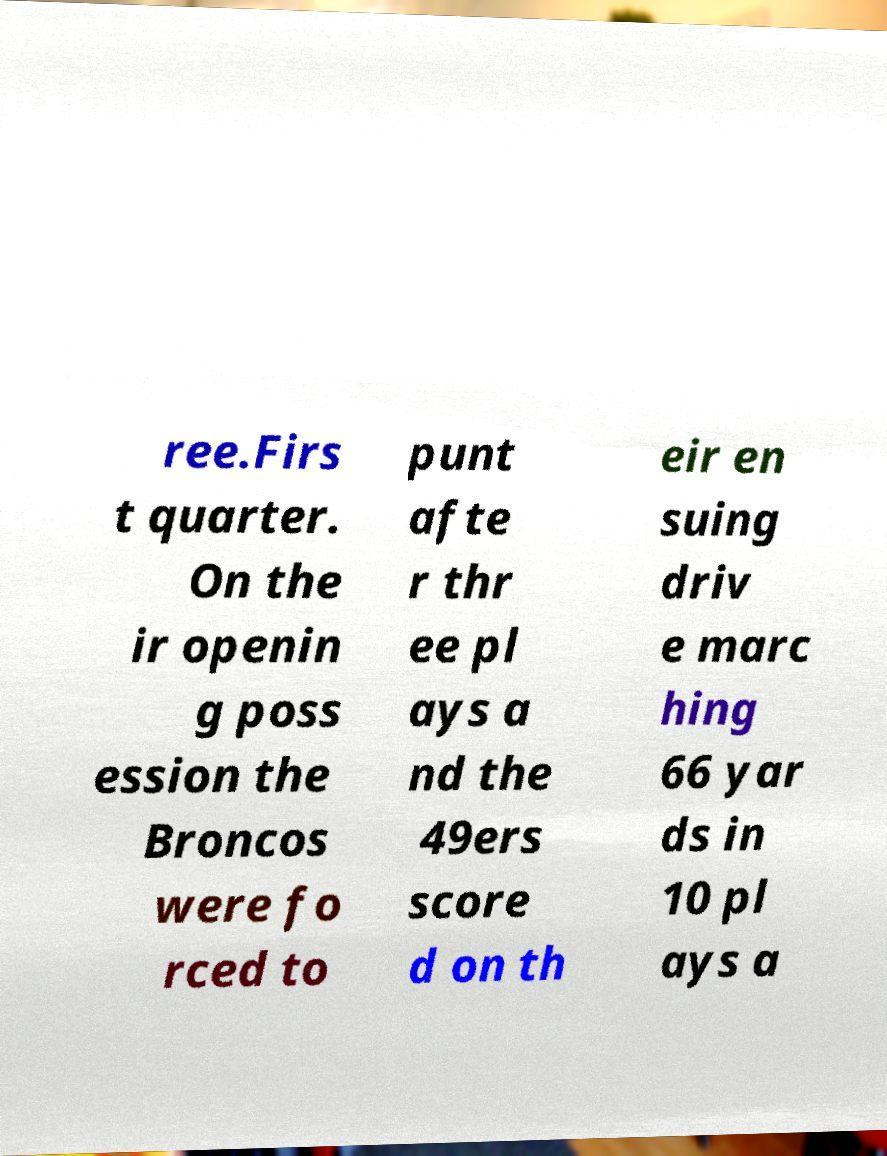There's text embedded in this image that I need extracted. Can you transcribe it verbatim? ree.Firs t quarter. On the ir openin g poss ession the Broncos were fo rced to punt afte r thr ee pl ays a nd the 49ers score d on th eir en suing driv e marc hing 66 yar ds in 10 pl ays a 